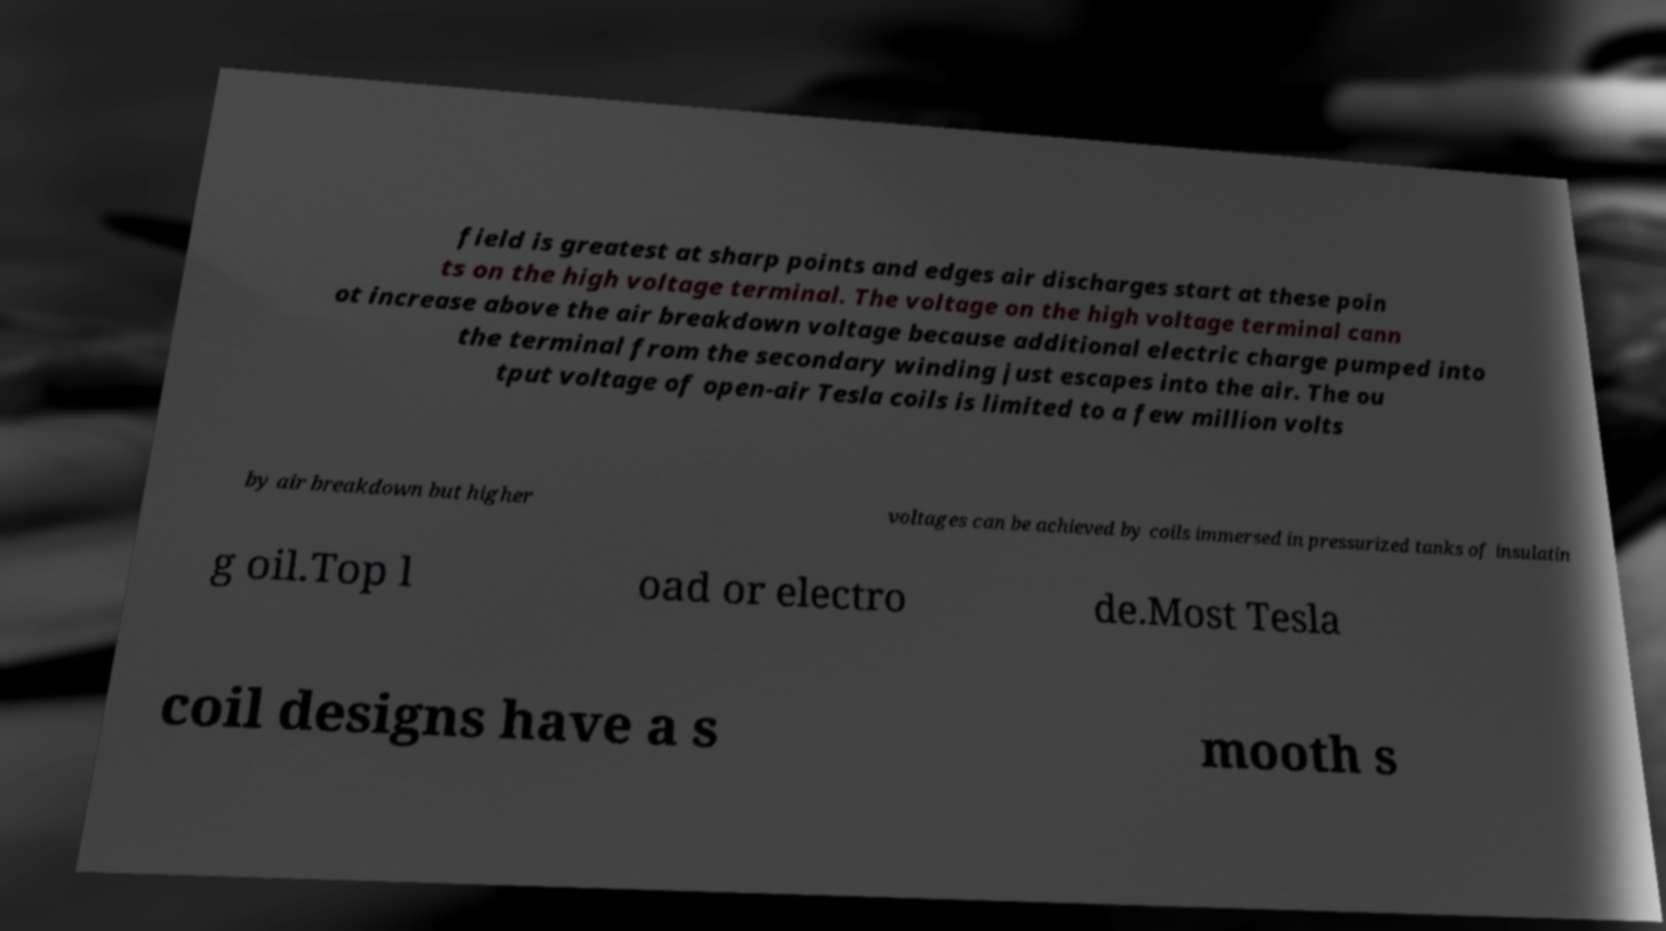Could you extract and type out the text from this image? field is greatest at sharp points and edges air discharges start at these poin ts on the high voltage terminal. The voltage on the high voltage terminal cann ot increase above the air breakdown voltage because additional electric charge pumped into the terminal from the secondary winding just escapes into the air. The ou tput voltage of open-air Tesla coils is limited to a few million volts by air breakdown but higher voltages can be achieved by coils immersed in pressurized tanks of insulatin g oil.Top l oad or electro de.Most Tesla coil designs have a s mooth s 